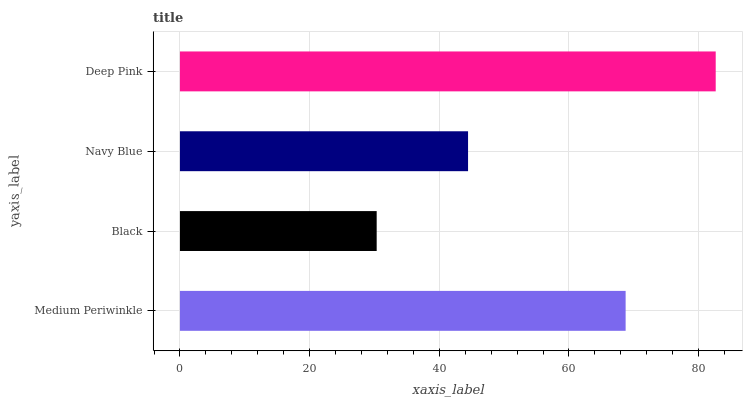Is Black the minimum?
Answer yes or no. Yes. Is Deep Pink the maximum?
Answer yes or no. Yes. Is Navy Blue the minimum?
Answer yes or no. No. Is Navy Blue the maximum?
Answer yes or no. No. Is Navy Blue greater than Black?
Answer yes or no. Yes. Is Black less than Navy Blue?
Answer yes or no. Yes. Is Black greater than Navy Blue?
Answer yes or no. No. Is Navy Blue less than Black?
Answer yes or no. No. Is Medium Periwinkle the high median?
Answer yes or no. Yes. Is Navy Blue the low median?
Answer yes or no. Yes. Is Deep Pink the high median?
Answer yes or no. No. Is Medium Periwinkle the low median?
Answer yes or no. No. 